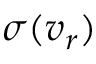Convert formula to latex. <formula><loc_0><loc_0><loc_500><loc_500>\sigma ( v _ { r } )</formula> 